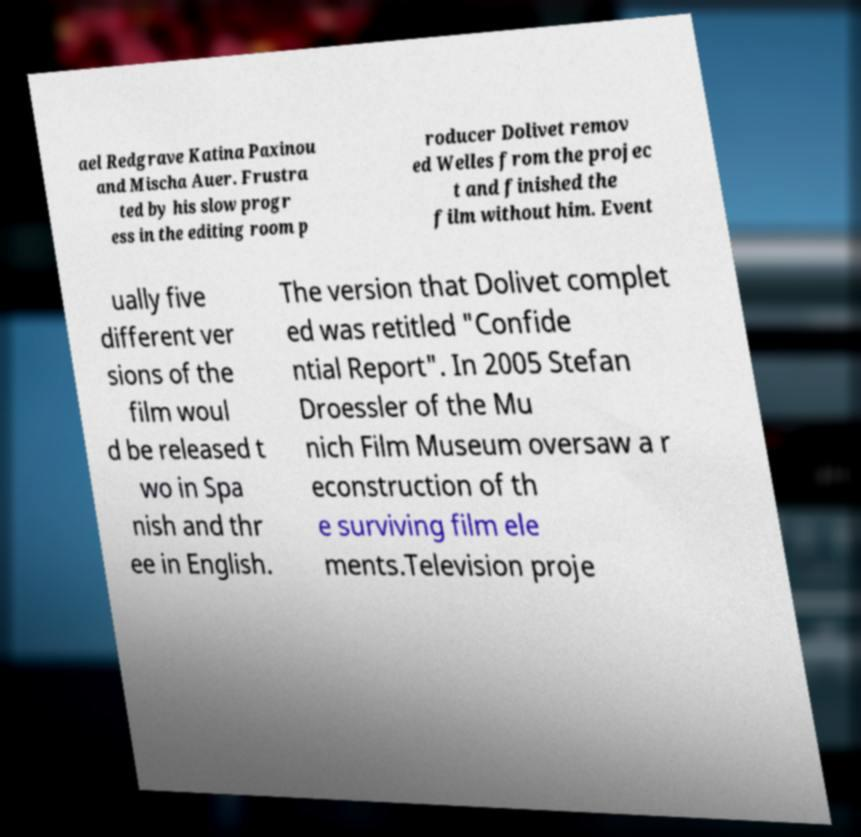Could you assist in decoding the text presented in this image and type it out clearly? ael Redgrave Katina Paxinou and Mischa Auer. Frustra ted by his slow progr ess in the editing room p roducer Dolivet remov ed Welles from the projec t and finished the film without him. Event ually five different ver sions of the film woul d be released t wo in Spa nish and thr ee in English. The version that Dolivet complet ed was retitled "Confide ntial Report". In 2005 Stefan Droessler of the Mu nich Film Museum oversaw a r econstruction of th e surviving film ele ments.Television proje 